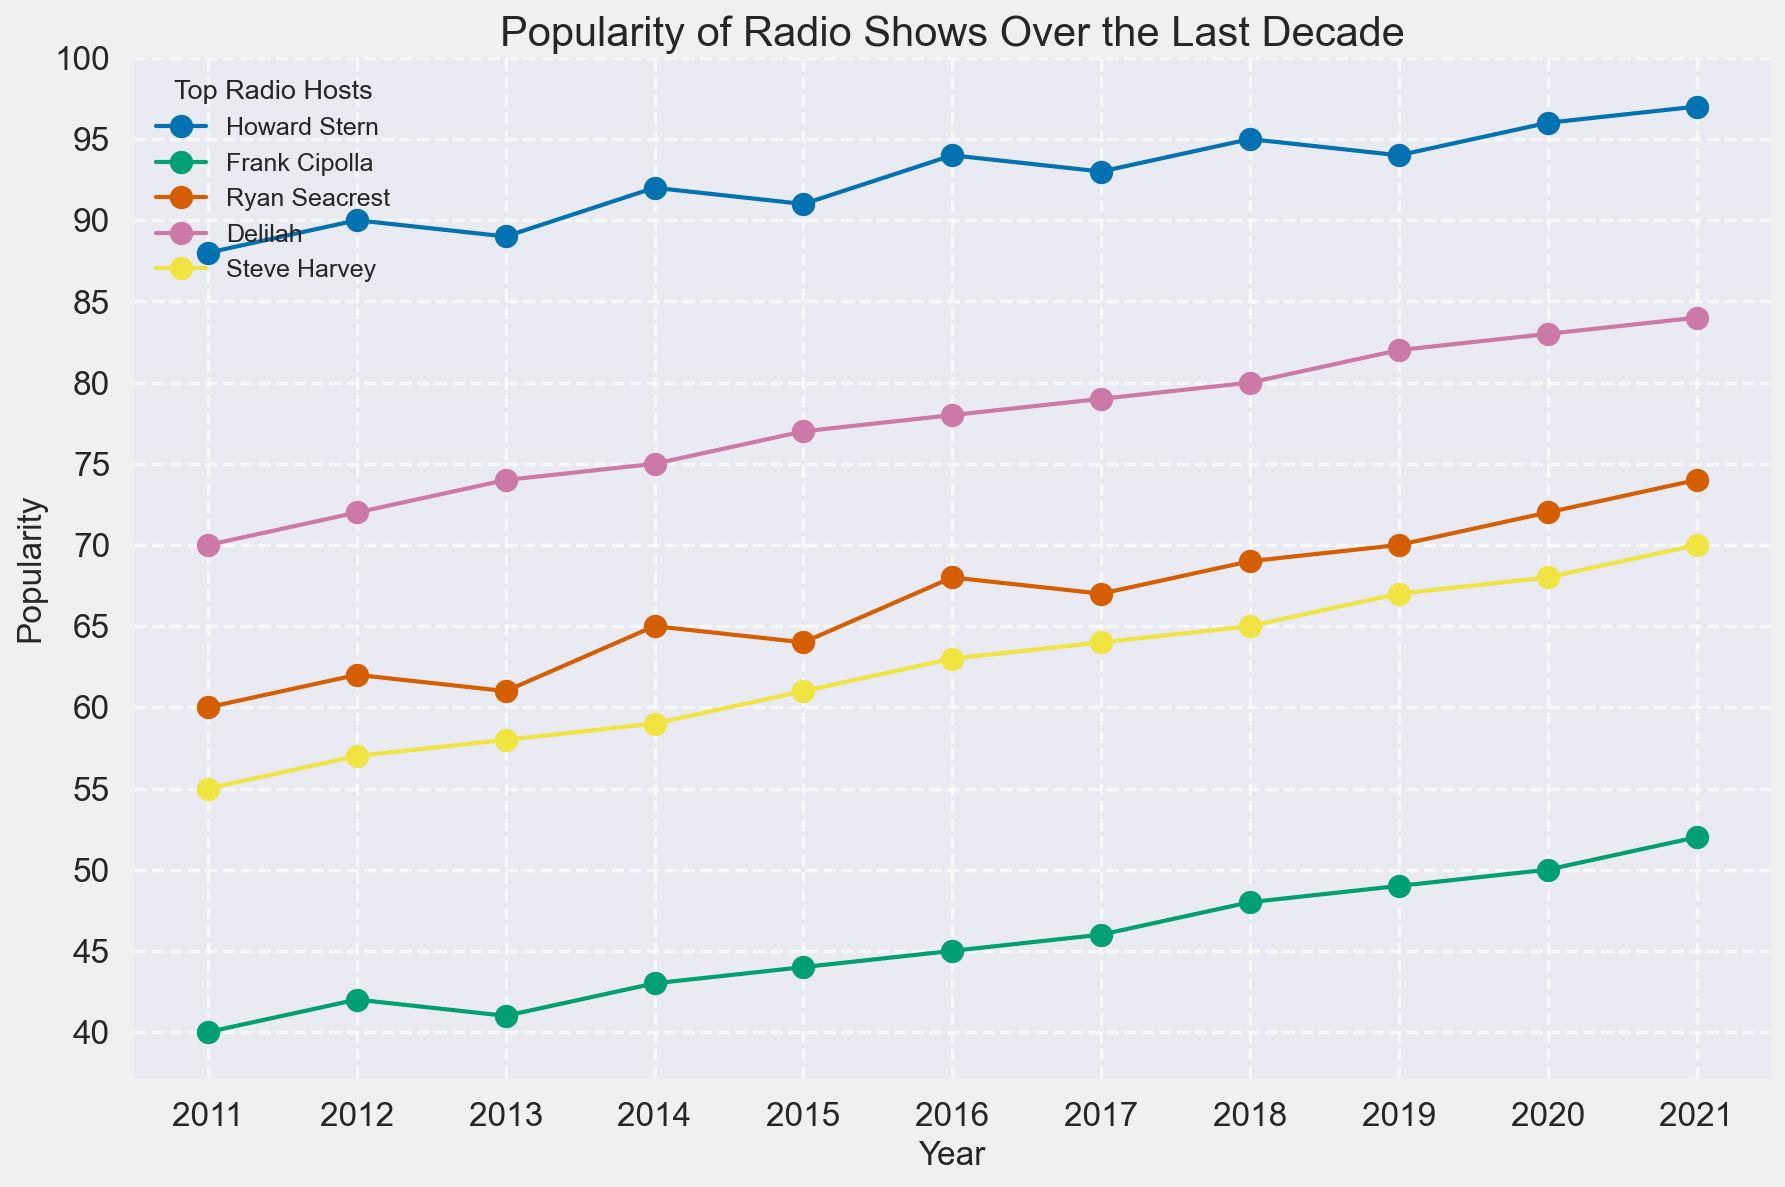Which radio host had the highest popularity throughout the decade? By examining the plot, it's evident that Howard Stern consistently has the highest popularity each year compared to other radio hosts.
Answer: Howard Stern What was the overall trend in popularity for Frank Cipolla from 2011 to 2021? Looking at the plot line for Frank Cipolla, there was a steady increase from 40 in 2011 to 52 in 2021.
Answer: Steady increase Which year did Delilah surpass 80 in popularity? Identify the year when Delilah’s popularity first crosses the 80 mark on the y-axis, which happened in 2019.
Answer: 2019 Who had a higher popularity in 2020, Frank Cipolla or Steve Harvey? Compare the values for 2020 from the lines representing Frank Cipolla (50) and Steve Harvey (68); Steve Harvey's value is higher.
Answer: Steve Harvey What was the difference in popularity between Howard Stern and Ryan Seacrest in 2021? In 2021, Howard Stern had a popularity of 97, and Ryan Seacrest had 74. The difference is 97 - 74 = 23.
Answer: 23 Did any host's popularity decrease over the decade? By examining the trends for all hosts, none of the lines show a consistent decrease over the entire time period; all hosts show either increasing or fluctuating trends.
Answer: No How much did Steve Harvey's popularity increase from 2016 to 2021? Steve Harvey's popularity went from 63 in 2016 to 70 in 2021. The increase is 70 - 63 = 7.
Answer: 7 By how many points did Frank Cipolla's popularity increase from 2011 to 2015? Frank Cipolla’s popularity increased from 40 in 2011 to 44 in 2015, which is an increase of 44 - 40 = 4 points.
Answer: 4 Which host had the most significant increase in popularity from 2018 to 2019? By comparing the increases for each host between 2018 and 2019: Howard Stern (0), Frank Cipolla (1), Ryan Seacrest (1), Delilah (2), Steve Harvey (2); Delilah and Steve Harvey have the most significant increase of 2 points.
Answer: Delilah and Steve Harvey 